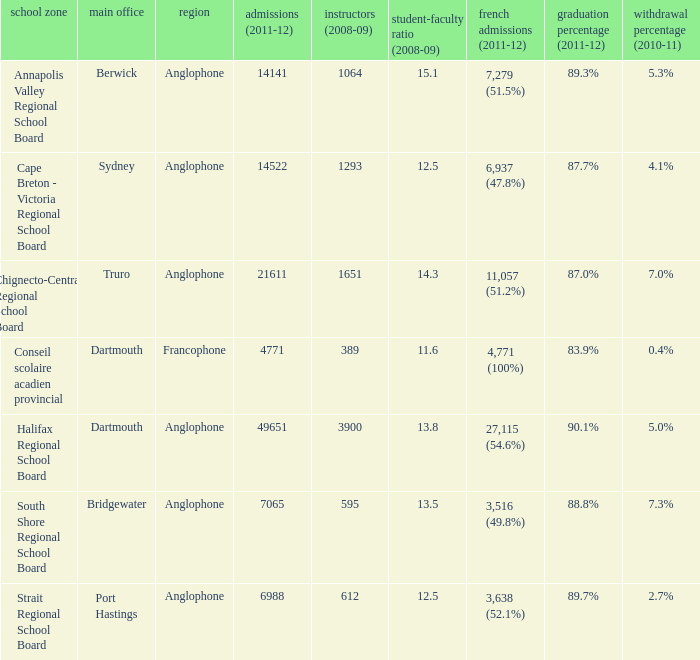What is the graduation rate for the school district with headquarters located in Sydney? 87.7%. 